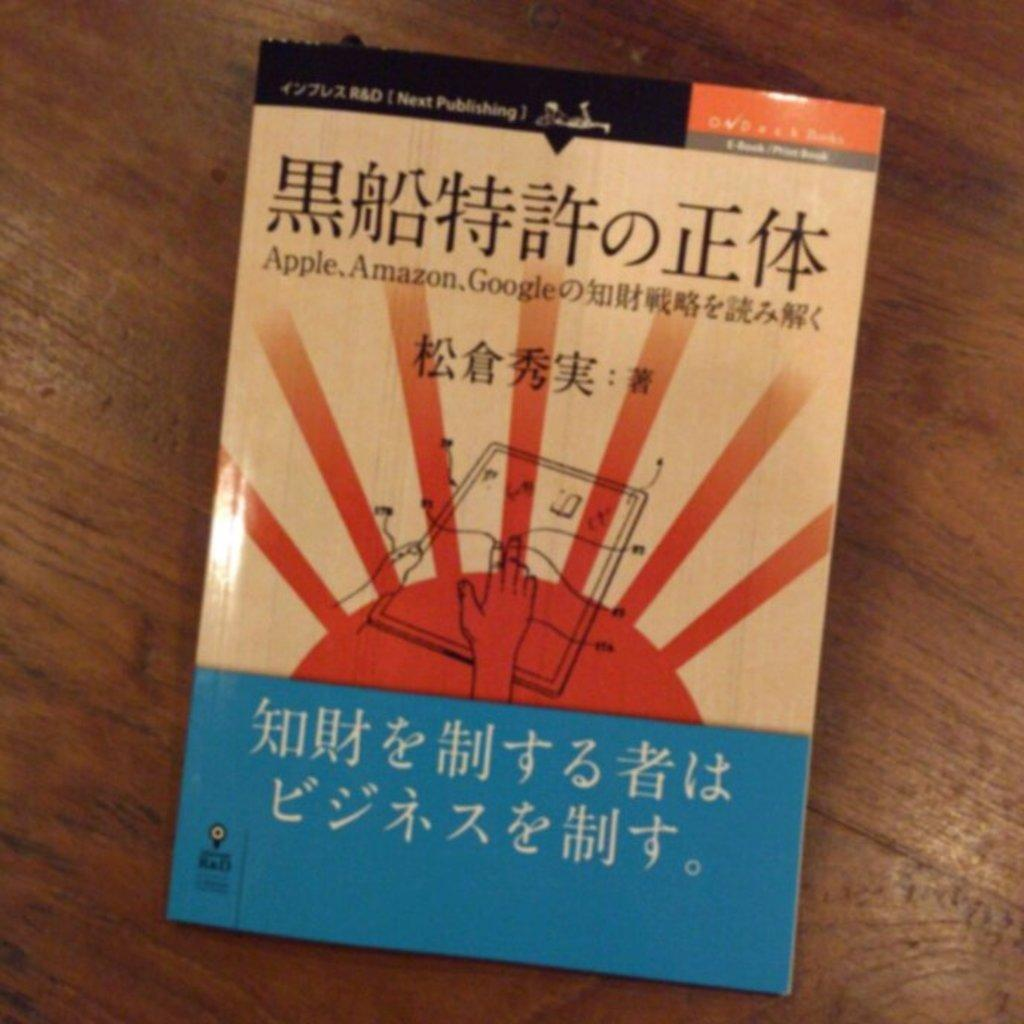<image>
Present a compact description of the photo's key features. A book that says Apple, Amazon, and Google with Chinese letters. 